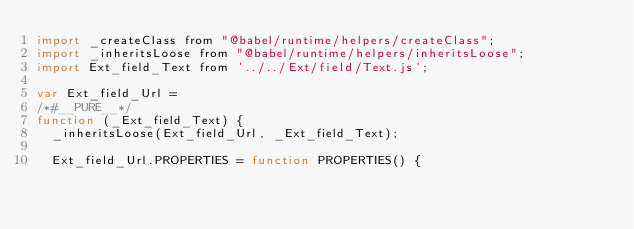Convert code to text. <code><loc_0><loc_0><loc_500><loc_500><_JavaScript_>import _createClass from "@babel/runtime/helpers/createClass";
import _inheritsLoose from "@babel/runtime/helpers/inheritsLoose";
import Ext_field_Text from '../../Ext/field/Text.js';

var Ext_field_Url =
/*#__PURE__*/
function (_Ext_field_Text) {
  _inheritsLoose(Ext_field_Url, _Ext_field_Text);

  Ext_field_Url.PROPERTIES = function PROPERTIES() {</code> 